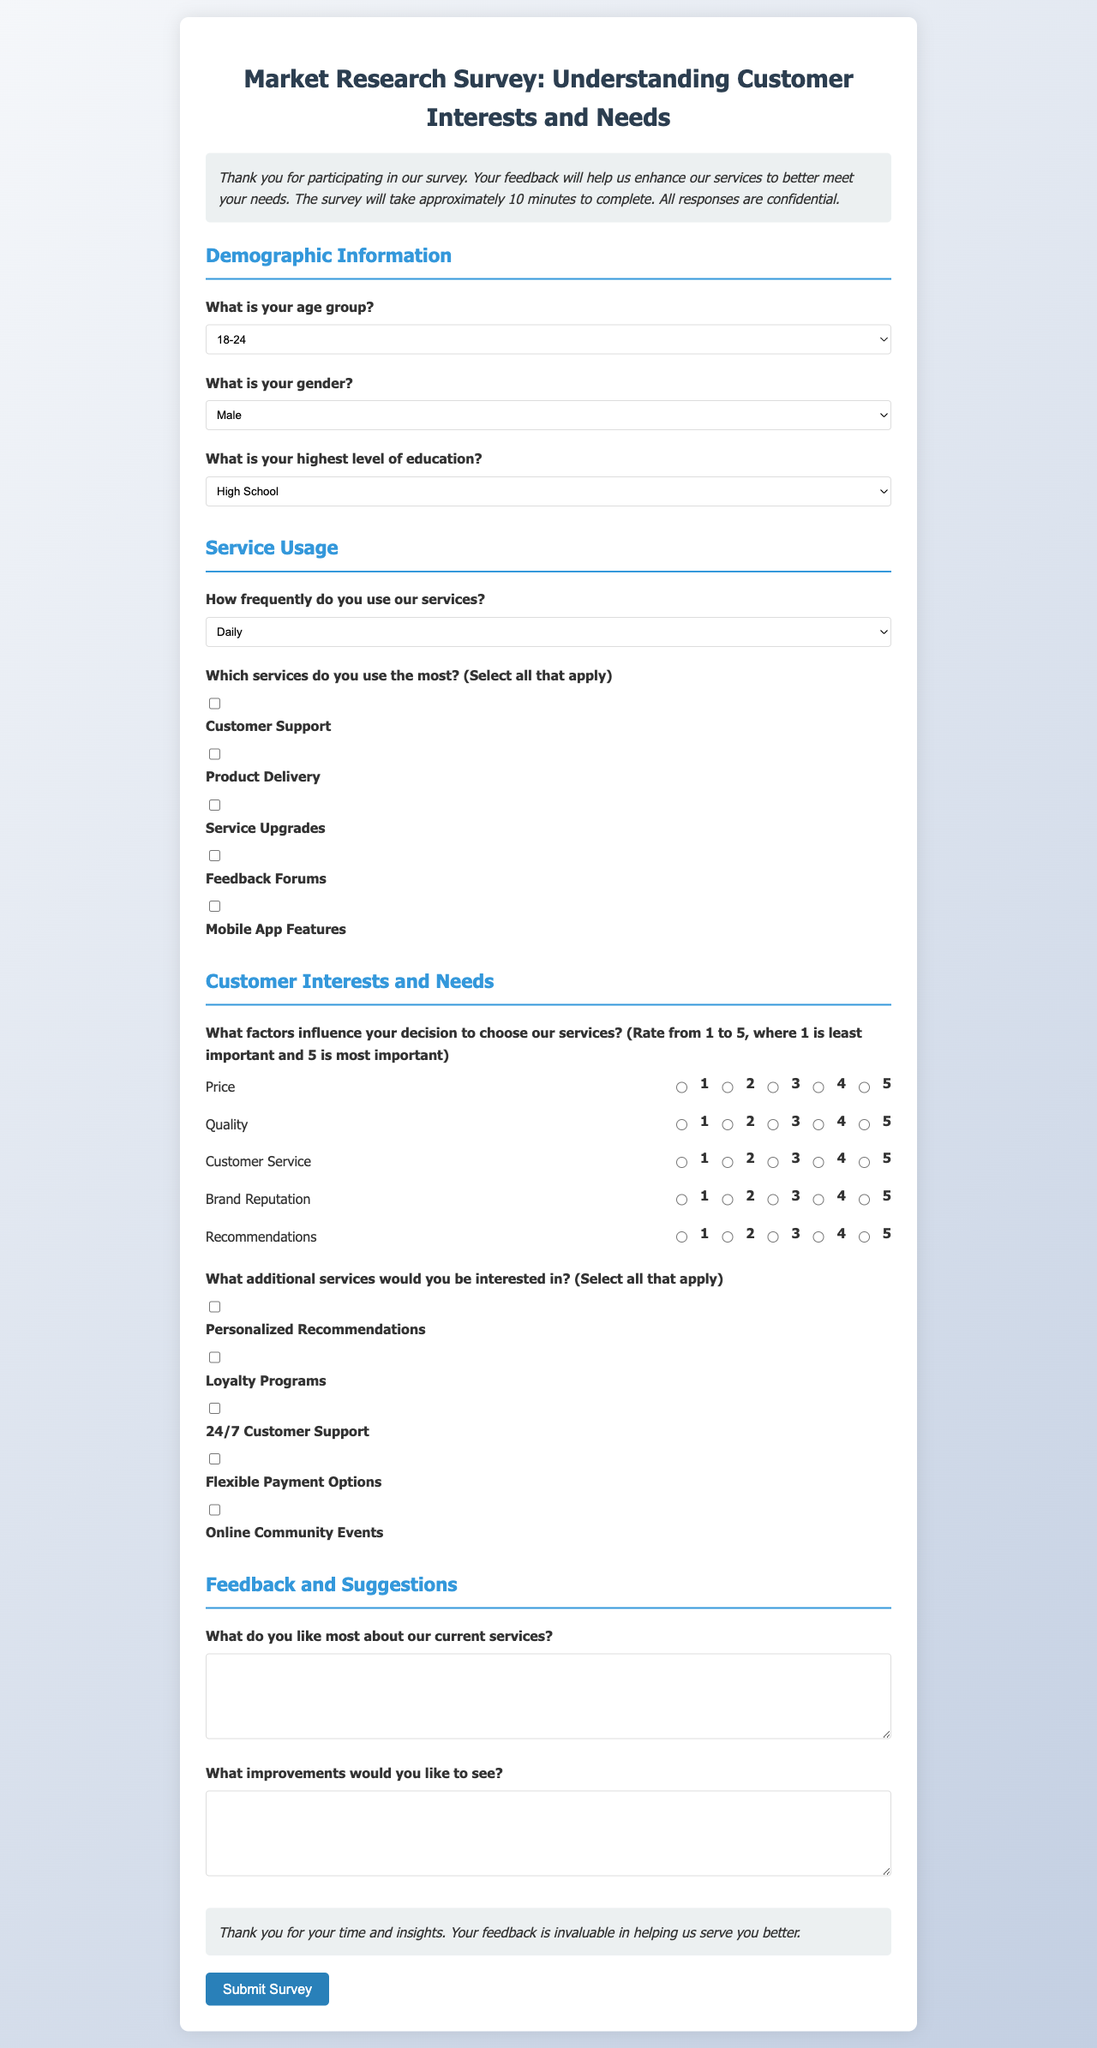What is the title of the document? The title can be found at the top of the document.
Answer: Market Research Survey: Understanding Customer Interests and Needs What is the age group with the highest option? The age group options are listed in a dropdown in the demographic section.
Answer: 55+ How many sections are there in the survey? The main divisions in the document categorize questions into different sections.
Answer: Four What is the least important factor influencing service choice according to the rating scale? The rating scale asks for importance on a scale of 1 to 5, where 1 indicates least important.
Answer: Price What type of feedback is requested in the last section? The last section contains open-ended questions about customer satisfaction.
Answer: Suggestions for improvements 